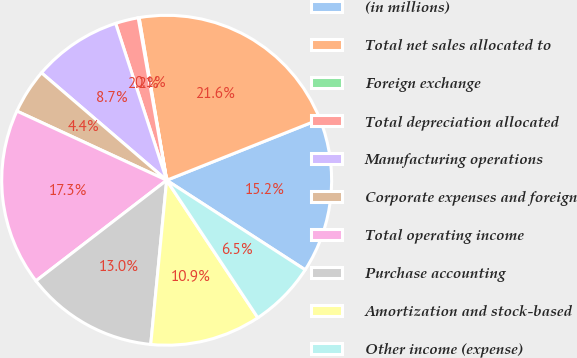<chart> <loc_0><loc_0><loc_500><loc_500><pie_chart><fcel>(in millions)<fcel>Total net sales allocated to<fcel>Foreign exchange<fcel>Total depreciation allocated<fcel>Manufacturing operations<fcel>Corporate expenses and foreign<fcel>Total operating income<fcel>Purchase accounting<fcel>Amortization and stock-based<fcel>Other income (expense)<nl><fcel>15.17%<fcel>21.64%<fcel>0.09%<fcel>2.24%<fcel>8.71%<fcel>4.4%<fcel>17.33%<fcel>13.02%<fcel>10.86%<fcel>6.55%<nl></chart> 